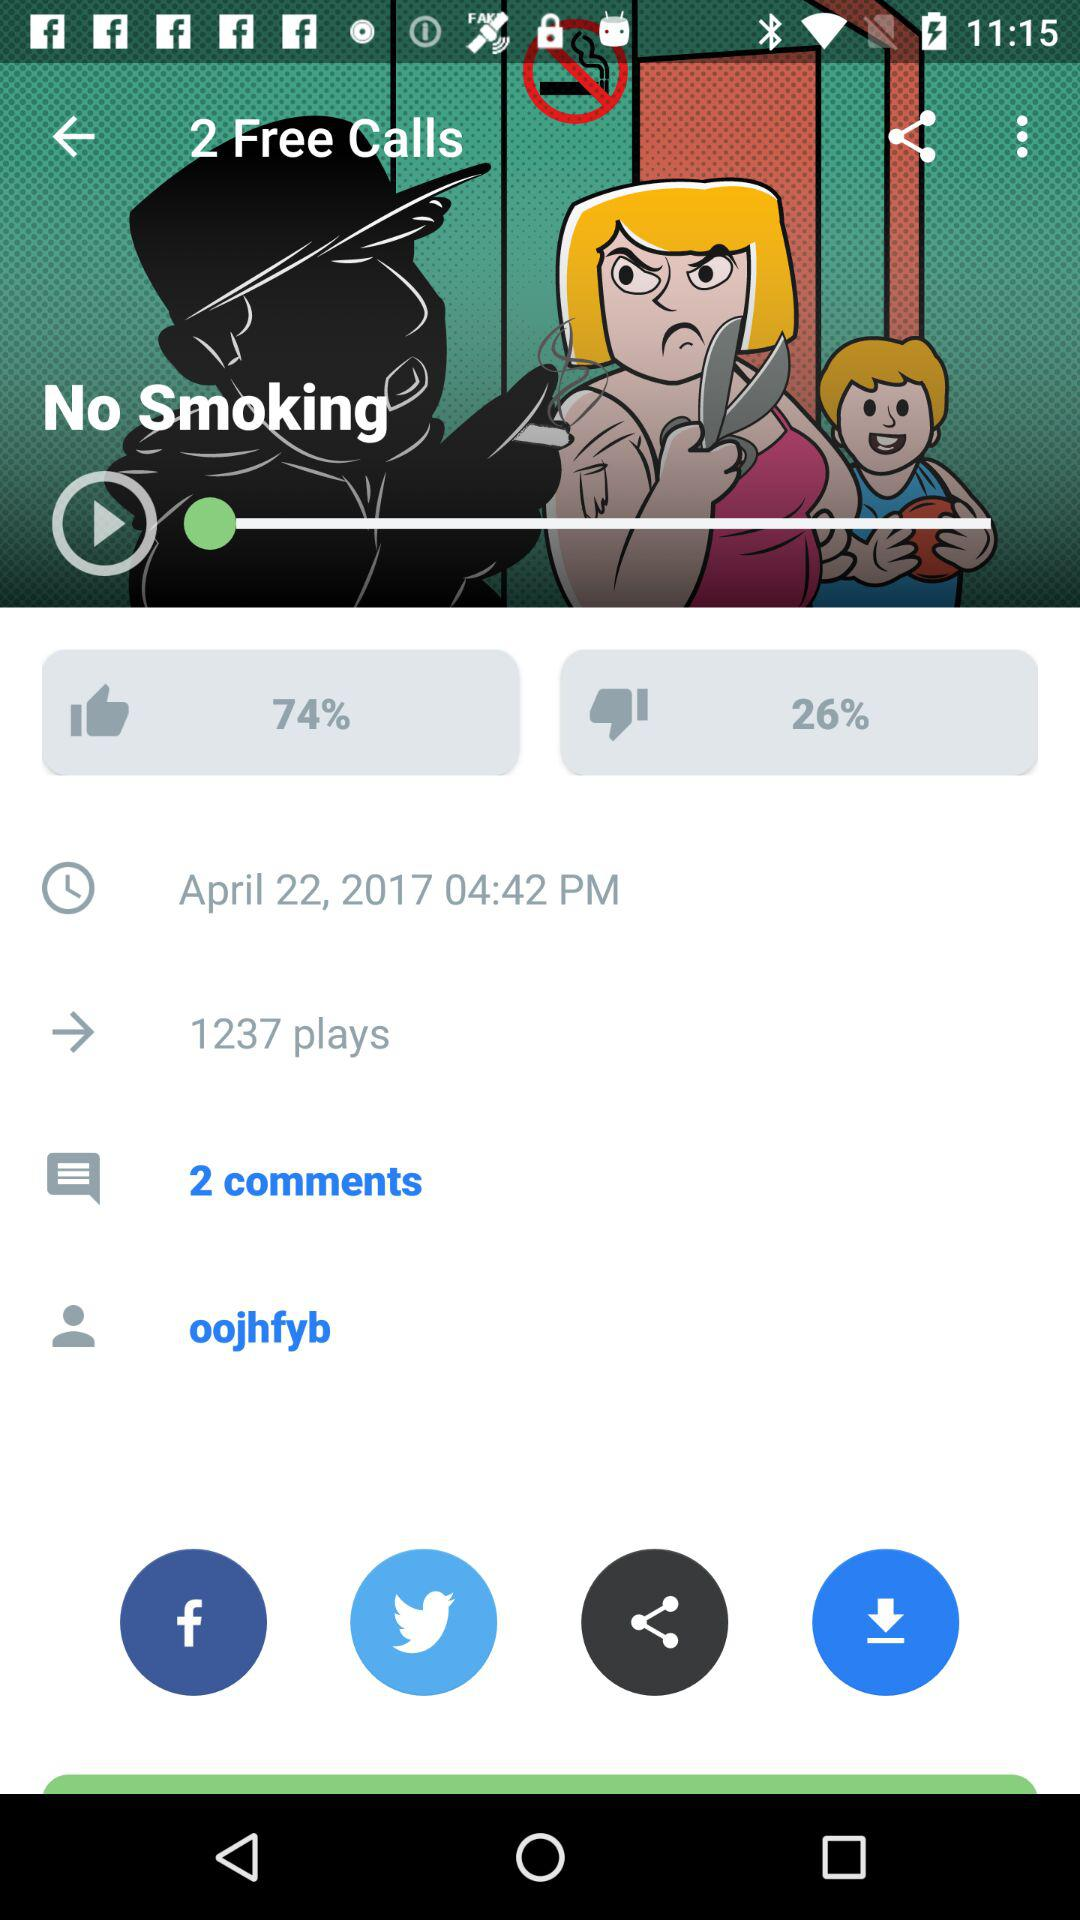How many more plays does the video have than comments?
Answer the question using a single word or phrase. 1235 